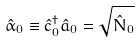<formula> <loc_0><loc_0><loc_500><loc_500>\hat { \alpha } _ { 0 } \equiv \hat { c } _ { 0 } ^ { \dag } \hat { a } _ { 0 } = \sqrt { \hat { N } _ { 0 } }</formula> 